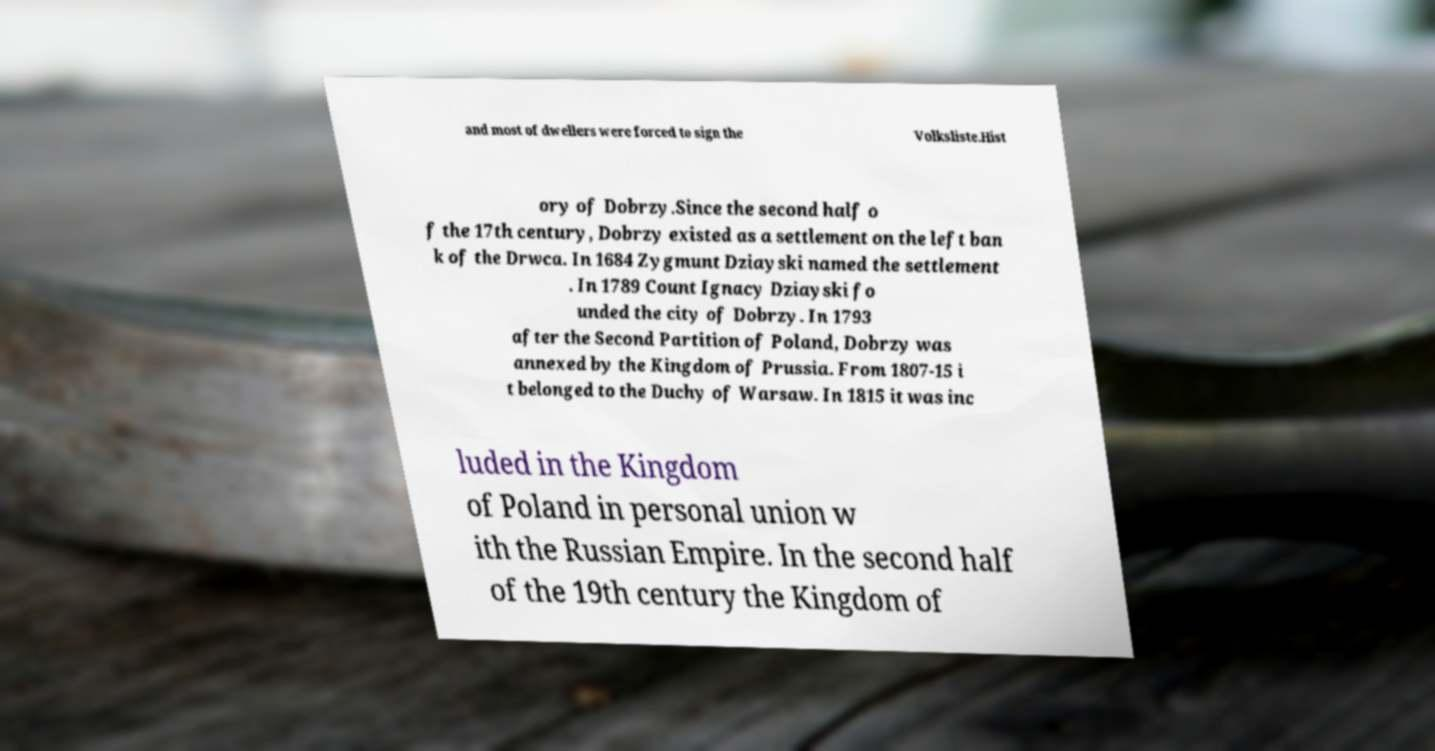Please identify and transcribe the text found in this image. and most of dwellers were forced to sign the Volksliste.Hist ory of Dobrzy.Since the second half o f the 17th century, Dobrzy existed as a settlement on the left ban k of the Drwca. In 1684 Zygmunt Dziayski named the settlement . In 1789 Count Ignacy Dziayski fo unded the city of Dobrzy. In 1793 after the Second Partition of Poland, Dobrzy was annexed by the Kingdom of Prussia. From 1807-15 i t belonged to the Duchy of Warsaw. In 1815 it was inc luded in the Kingdom of Poland in personal union w ith the Russian Empire. In the second half of the 19th century the Kingdom of 